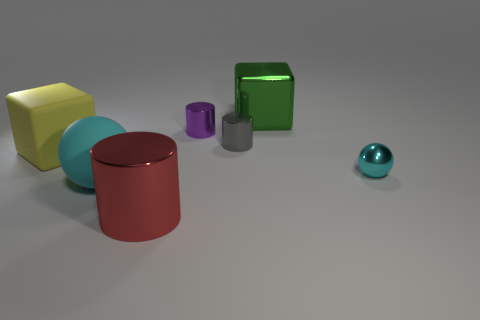Is the cube in front of the purple metal cylinder made of the same material as the big green object?
Offer a very short reply. No. There is a object that is both left of the red cylinder and behind the small cyan object; what is its size?
Offer a terse response. Large. How big is the matte object to the right of the yellow rubber thing?
Keep it short and to the point. Large. What is the shape of the large object that is the same color as the small ball?
Provide a succinct answer. Sphere. The big rubber object behind the sphere that is on the right side of the cube on the right side of the large yellow rubber block is what shape?
Keep it short and to the point. Cube. How many other objects are there of the same shape as the purple thing?
Keep it short and to the point. 2. What number of metallic objects are either big cyan objects or blue cubes?
Offer a very short reply. 0. What material is the sphere left of the cyan thing behind the matte sphere?
Provide a short and direct response. Rubber. Are there more purple objects that are in front of the yellow block than brown things?
Offer a very short reply. No. Is there a big cyan object made of the same material as the big green block?
Keep it short and to the point. No. 